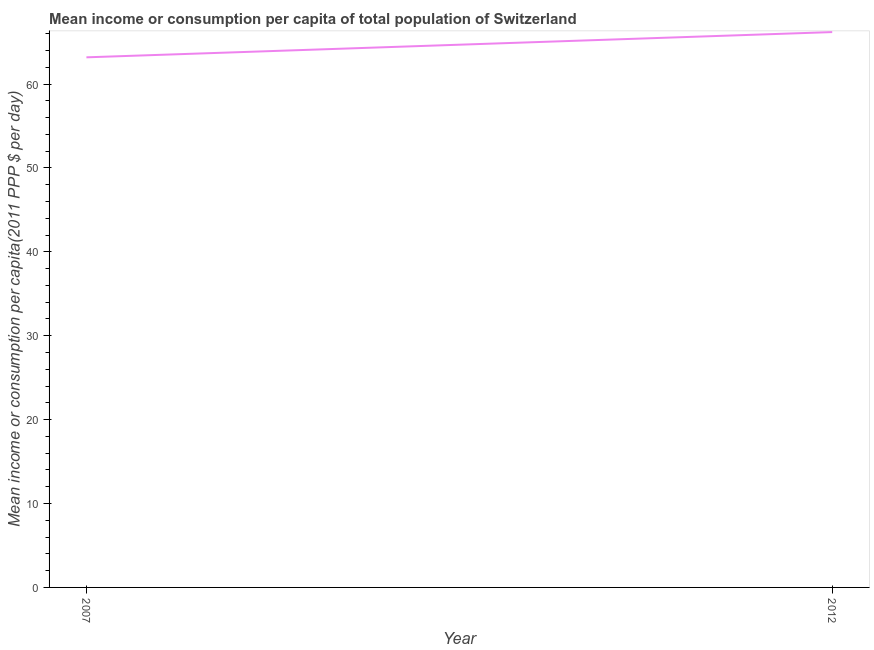What is the mean income or consumption in 2012?
Your answer should be very brief. 66.19. Across all years, what is the maximum mean income or consumption?
Provide a succinct answer. 66.19. Across all years, what is the minimum mean income or consumption?
Your response must be concise. 63.18. In which year was the mean income or consumption maximum?
Give a very brief answer. 2012. What is the sum of the mean income or consumption?
Your response must be concise. 129.37. What is the difference between the mean income or consumption in 2007 and 2012?
Provide a short and direct response. -3.01. What is the average mean income or consumption per year?
Offer a terse response. 64.69. What is the median mean income or consumption?
Ensure brevity in your answer.  64.69. Do a majority of the years between 2012 and 2007 (inclusive) have mean income or consumption greater than 14 $?
Ensure brevity in your answer.  No. What is the ratio of the mean income or consumption in 2007 to that in 2012?
Give a very brief answer. 0.95. Is the mean income or consumption in 2007 less than that in 2012?
Your answer should be compact. Yes. In how many years, is the mean income or consumption greater than the average mean income or consumption taken over all years?
Your response must be concise. 1. How many lines are there?
Your answer should be very brief. 1. How many years are there in the graph?
Your answer should be very brief. 2. What is the difference between two consecutive major ticks on the Y-axis?
Offer a very short reply. 10. Does the graph contain any zero values?
Your answer should be very brief. No. What is the title of the graph?
Keep it short and to the point. Mean income or consumption per capita of total population of Switzerland. What is the label or title of the X-axis?
Your answer should be compact. Year. What is the label or title of the Y-axis?
Your answer should be compact. Mean income or consumption per capita(2011 PPP $ per day). What is the Mean income or consumption per capita(2011 PPP $ per day) in 2007?
Your response must be concise. 63.18. What is the Mean income or consumption per capita(2011 PPP $ per day) of 2012?
Give a very brief answer. 66.19. What is the difference between the Mean income or consumption per capita(2011 PPP $ per day) in 2007 and 2012?
Provide a short and direct response. -3.01. What is the ratio of the Mean income or consumption per capita(2011 PPP $ per day) in 2007 to that in 2012?
Offer a terse response. 0.95. 